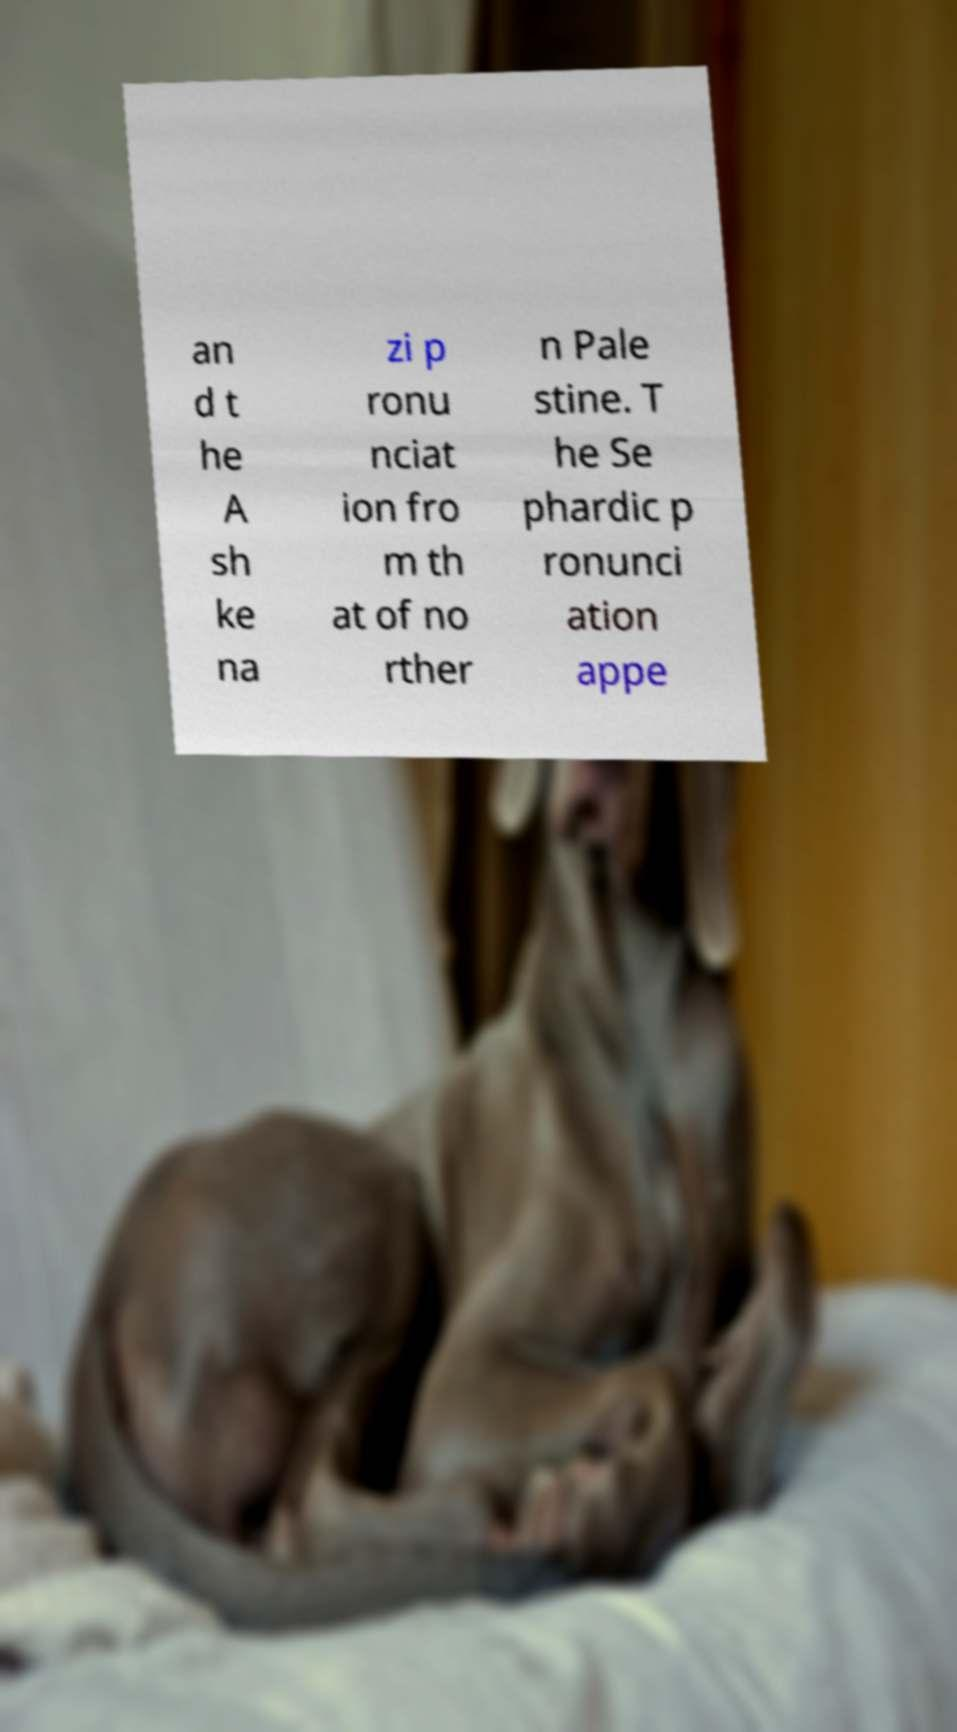I need the written content from this picture converted into text. Can you do that? an d t he A sh ke na zi p ronu nciat ion fro m th at of no rther n Pale stine. T he Se phardic p ronunci ation appe 